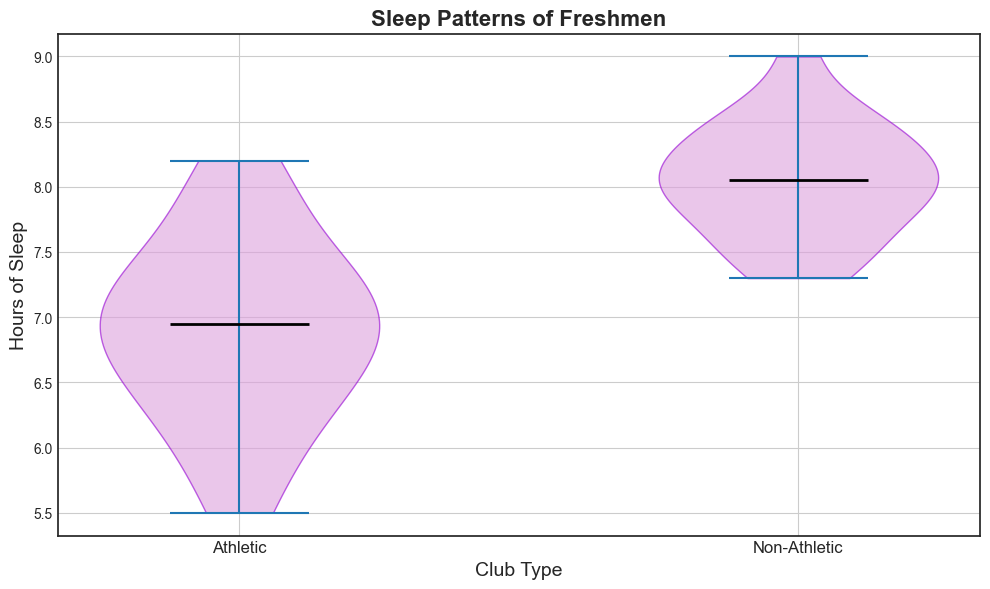What is the median value of sleep hours for freshmen in athletic clubs? The violin plot shows a central line that represents the median value. Look at the median line in the Athletic group violin plot.
Answer: 7.0 Which group of freshmen, athletic or non-athletic, has higher median hours of sleep? Compare the height of the median lines in both violin plots. The Non-Athletic group’s median line is higher than the Athletic group’s.
Answer: Non-Athletic What is the range of sleep hours for freshmen in non-athletic clubs? The range is determined by finding the difference between the maximum and minimum points of the data distribution. Look at the highest and lowest points of the Non-Athletic group’s violin plot.
Answer: 7.3 to 9.0 Which group shows a wider distribution of sleep hours? Compare the width of the violin plots. The group with the wider plot has a more varied distribution.
Answer: Athletic If you need at least 8 hours of sleep, which group would be better to join? Look at the portion of the violins above the 8-hour mark. The Non-Athletic group shows a thicker portion above this threshold.
Answer: Non-Athletic How do the upper quartile values compare between the two groups? Upper quartile values are approximately the line above the median. The Non-Athletic group's upper quartile appears to be higher than the Athletic group's.
Answer: Non-Athletic higher Describe the visual difference in the shape of the violin plots for both groups. Look at the overall shape of the violin plots. The Athletic group is more spread out vertically while the Non-Athletic group has a more concentrated, taller shape.
Answer: Athletic is wider, Non-Athletic is taller What can be inferred about the consistency of sleep patterns between the groups? Identify which violin plot has more consistent (narrower) distribution. The Non-Athletic group shows a taller and narrower plot, indicating more consistent sleep patterns.
Answer: Non-Athletic more consistent 